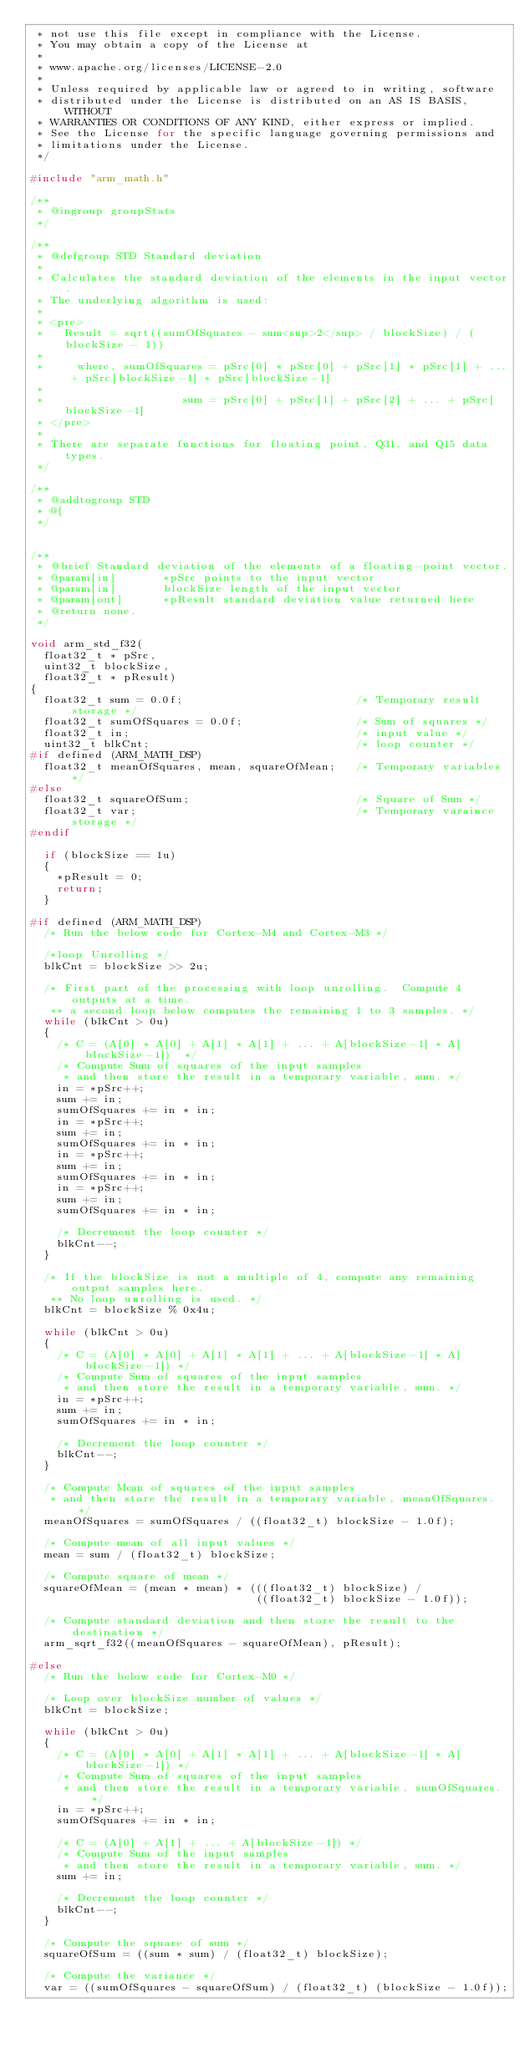<code> <loc_0><loc_0><loc_500><loc_500><_C_> * not use this file except in compliance with the License.
 * You may obtain a copy of the License at
 *
 * www.apache.org/licenses/LICENSE-2.0
 *
 * Unless required by applicable law or agreed to in writing, software
 * distributed under the License is distributed on an AS IS BASIS, WITHOUT
 * WARRANTIES OR CONDITIONS OF ANY KIND, either express or implied.
 * See the License for the specific language governing permissions and
 * limitations under the License.
 */

#include "arm_math.h"

/**
 * @ingroup groupStats
 */

/**
 * @defgroup STD Standard deviation
 *
 * Calculates the standard deviation of the elements in the input vector.
 * The underlying algorithm is used:
 *
 * <pre>
 *   Result = sqrt((sumOfSquares - sum<sup>2</sup> / blockSize) / (blockSize - 1))
 *
 *     where, sumOfSquares = pSrc[0] * pSrc[0] + pSrc[1] * pSrc[1] + ... + pSrc[blockSize-1] * pSrc[blockSize-1]
 *
 *                     sum = pSrc[0] + pSrc[1] + pSrc[2] + ... + pSrc[blockSize-1]
 * </pre>
 *
 * There are separate functions for floating point, Q31, and Q15 data types.
 */

/**
 * @addtogroup STD
 * @{
 */


/**
 * @brief Standard deviation of the elements of a floating-point vector.
 * @param[in]       *pSrc points to the input vector
 * @param[in]       blockSize length of the input vector
 * @param[out]      *pResult standard deviation value returned here
 * @return none.
 */

void arm_std_f32(
  float32_t * pSrc,
  uint32_t blockSize,
  float32_t * pResult)
{
  float32_t sum = 0.0f;                          /* Temporary result storage */
  float32_t sumOfSquares = 0.0f;                 /* Sum of squares */
  float32_t in;                                  /* input value */
  uint32_t blkCnt;                               /* loop counter */
#if defined (ARM_MATH_DSP)
  float32_t meanOfSquares, mean, squareOfMean;   /* Temporary variables */
#else
  float32_t squareOfSum;                         /* Square of Sum */
  float32_t var;                                 /* Temporary varaince storage */
#endif

  if (blockSize == 1u)
  {
    *pResult = 0;
    return;
  }

#if defined (ARM_MATH_DSP)
  /* Run the below code for Cortex-M4 and Cortex-M3 */

  /*loop Unrolling */
  blkCnt = blockSize >> 2u;

  /* First part of the processing with loop unrolling.  Compute 4 outputs at a time.
   ** a second loop below computes the remaining 1 to 3 samples. */
  while (blkCnt > 0u)
  {
    /* C = (A[0] * A[0] + A[1] * A[1] + ... + A[blockSize-1] * A[blockSize-1])  */
    /* Compute Sum of squares of the input samples
     * and then store the result in a temporary variable, sum. */
    in = *pSrc++;
    sum += in;
    sumOfSquares += in * in;
    in = *pSrc++;
    sum += in;
    sumOfSquares += in * in;
    in = *pSrc++;
    sum += in;
    sumOfSquares += in * in;
    in = *pSrc++;
    sum += in;
    sumOfSquares += in * in;

    /* Decrement the loop counter */
    blkCnt--;
  }

  /* If the blockSize is not a multiple of 4, compute any remaining output samples here.
   ** No loop unrolling is used. */
  blkCnt = blockSize % 0x4u;

  while (blkCnt > 0u)
  {
    /* C = (A[0] * A[0] + A[1] * A[1] + ... + A[blockSize-1] * A[blockSize-1]) */
    /* Compute Sum of squares of the input samples
     * and then store the result in a temporary variable, sum. */
    in = *pSrc++;
    sum += in;
    sumOfSquares += in * in;

    /* Decrement the loop counter */
    blkCnt--;
  }

  /* Compute Mean of squares of the input samples
   * and then store the result in a temporary variable, meanOfSquares. */
  meanOfSquares = sumOfSquares / ((float32_t) blockSize - 1.0f);

  /* Compute mean of all input values */
  mean = sum / (float32_t) blockSize;

  /* Compute square of mean */
  squareOfMean = (mean * mean) * (((float32_t) blockSize) /
                                  ((float32_t) blockSize - 1.0f));

  /* Compute standard deviation and then store the result to the destination */
  arm_sqrt_f32((meanOfSquares - squareOfMean), pResult);

#else
  /* Run the below code for Cortex-M0 */

  /* Loop over blockSize number of values */
  blkCnt = blockSize;

  while (blkCnt > 0u)
  {
    /* C = (A[0] * A[0] + A[1] * A[1] + ... + A[blockSize-1] * A[blockSize-1]) */
    /* Compute Sum of squares of the input samples
     * and then store the result in a temporary variable, sumOfSquares. */
    in = *pSrc++;
    sumOfSquares += in * in;

    /* C = (A[0] + A[1] + ... + A[blockSize-1]) */
    /* Compute Sum of the input samples
     * and then store the result in a temporary variable, sum. */
    sum += in;

    /* Decrement the loop counter */
    blkCnt--;
  }

  /* Compute the square of sum */
  squareOfSum = ((sum * sum) / (float32_t) blockSize);

  /* Compute the variance */
  var = ((sumOfSquares - squareOfSum) / (float32_t) (blockSize - 1.0f));
</code> 